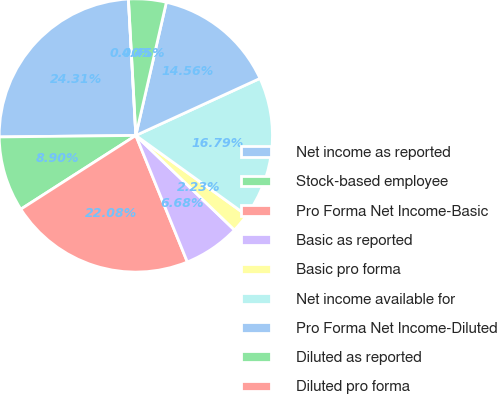Convert chart. <chart><loc_0><loc_0><loc_500><loc_500><pie_chart><fcel>Net income as reported<fcel>Stock-based employee<fcel>Pro Forma Net Income-Basic<fcel>Basic as reported<fcel>Basic pro forma<fcel>Net income available for<fcel>Pro Forma Net Income-Diluted<fcel>Diluted as reported<fcel>Diluted pro forma<nl><fcel>24.31%<fcel>8.9%<fcel>22.08%<fcel>6.68%<fcel>2.23%<fcel>16.79%<fcel>14.56%<fcel>4.45%<fcel>0.0%<nl></chart> 